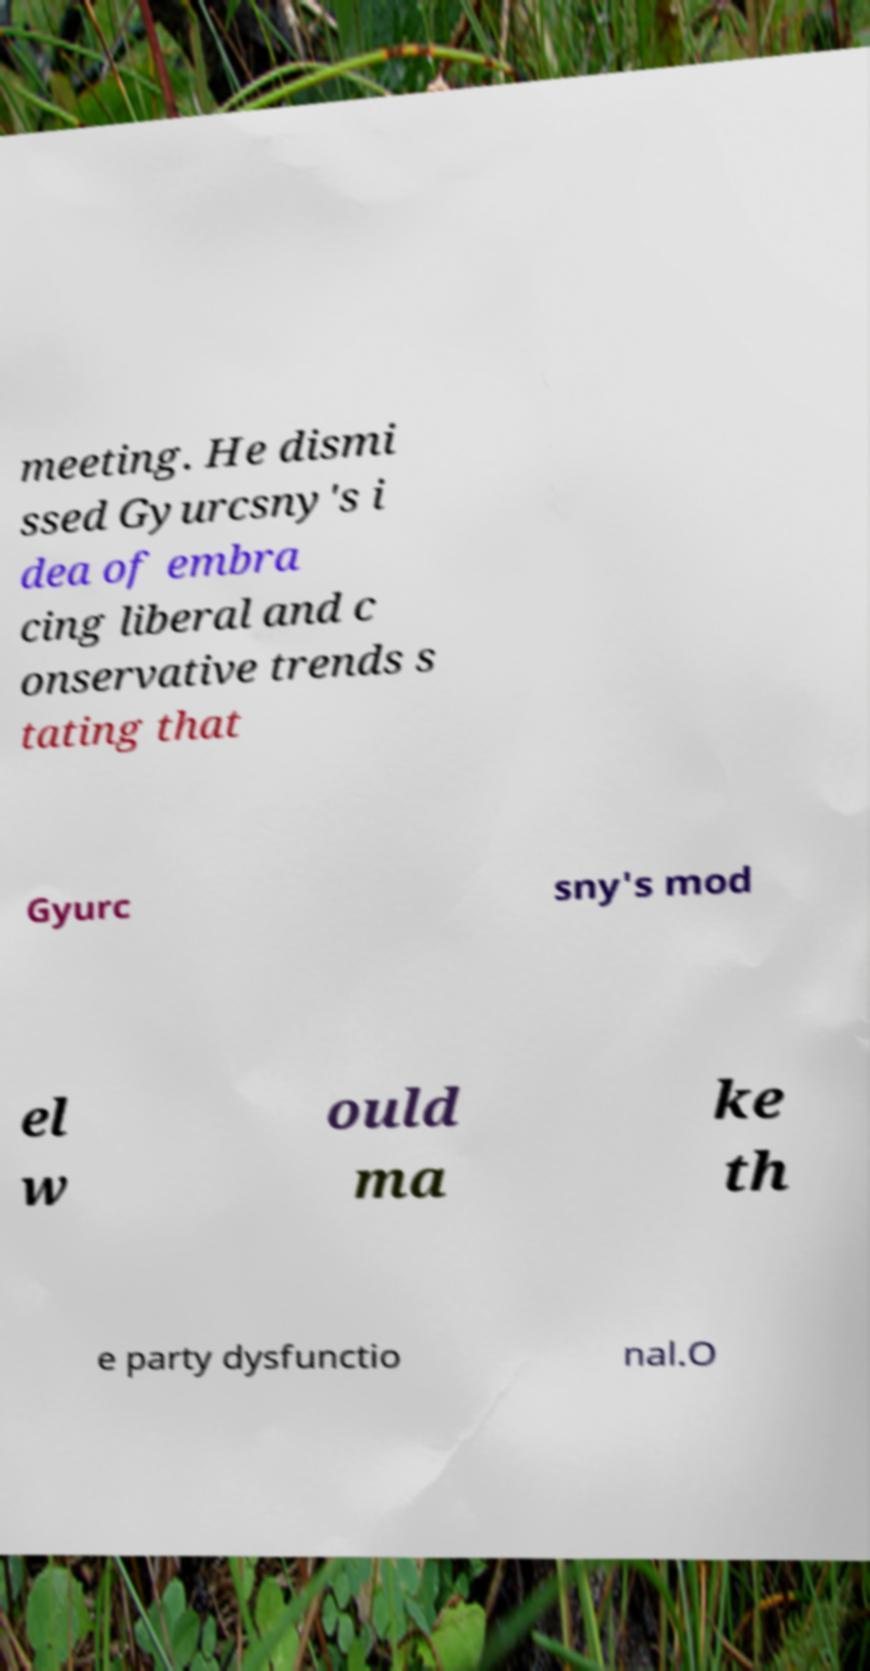Can you read and provide the text displayed in the image?This photo seems to have some interesting text. Can you extract and type it out for me? meeting. He dismi ssed Gyurcsny's i dea of embra cing liberal and c onservative trends s tating that Gyurc sny's mod el w ould ma ke th e party dysfunctio nal.O 